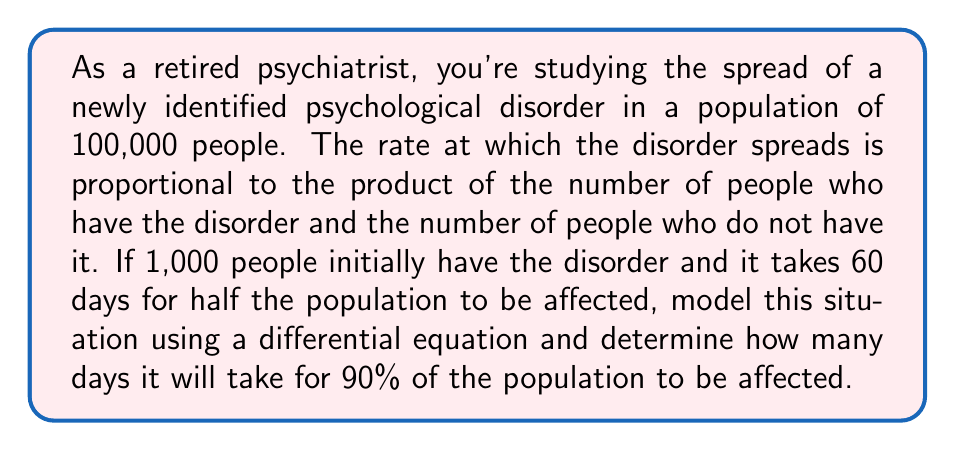Solve this math problem. Let's approach this step-by-step:

1) Let $P(t)$ be the number of people with the disorder at time $t$ (in days).

2) The initial condition is $P(0) = 1000$.

3) The rate of change of $P$ with respect to $t$ is proportional to $P(100000-P)$. This gives us the differential equation:

   $$\frac{dP}{dt} = kP(100000-P)$$

   where $k$ is the constant of proportionality.

4) To find $k$, we use the information that half the population is affected after 60 days:

   $P(60) = 50000$

5) The solution to this logistic differential equation is:

   $$P(t) = \frac{100000}{1 + Ae^{-100000kt}}$$

   where $A = \frac{100000-P(0)}{P(0)} = 99$

6) Substituting $t=60$ and $P(60)=50000$:

   $$50000 = \frac{100000}{1 + 99e^{-6000000k}}$$

7) Solving this:

   $$e^{-6000000k} = 1$$
   $$-6000000k = \ln(1) = 0$$
   $$k = \frac{\ln(99)}{6000000} \approx 7.644 \times 10^{-7}$$

8) Now, to find when 90% of the population is affected, we solve:

   $$90000 = \frac{100000}{1 + 99e^{-100000kt}}$$

9) Solving this:

   $$e^{-100000kt} = \frac{1}{9}$$
   $$-100000kt = \ln(\frac{1}{9})$$
   $$t = \frac{-\ln(\frac{1}{9})}{100000k} \approx 114.47$$

Therefore, it will take approximately 114.47 days for 90% of the population to be affected.
Answer: Approximately 114.47 days 